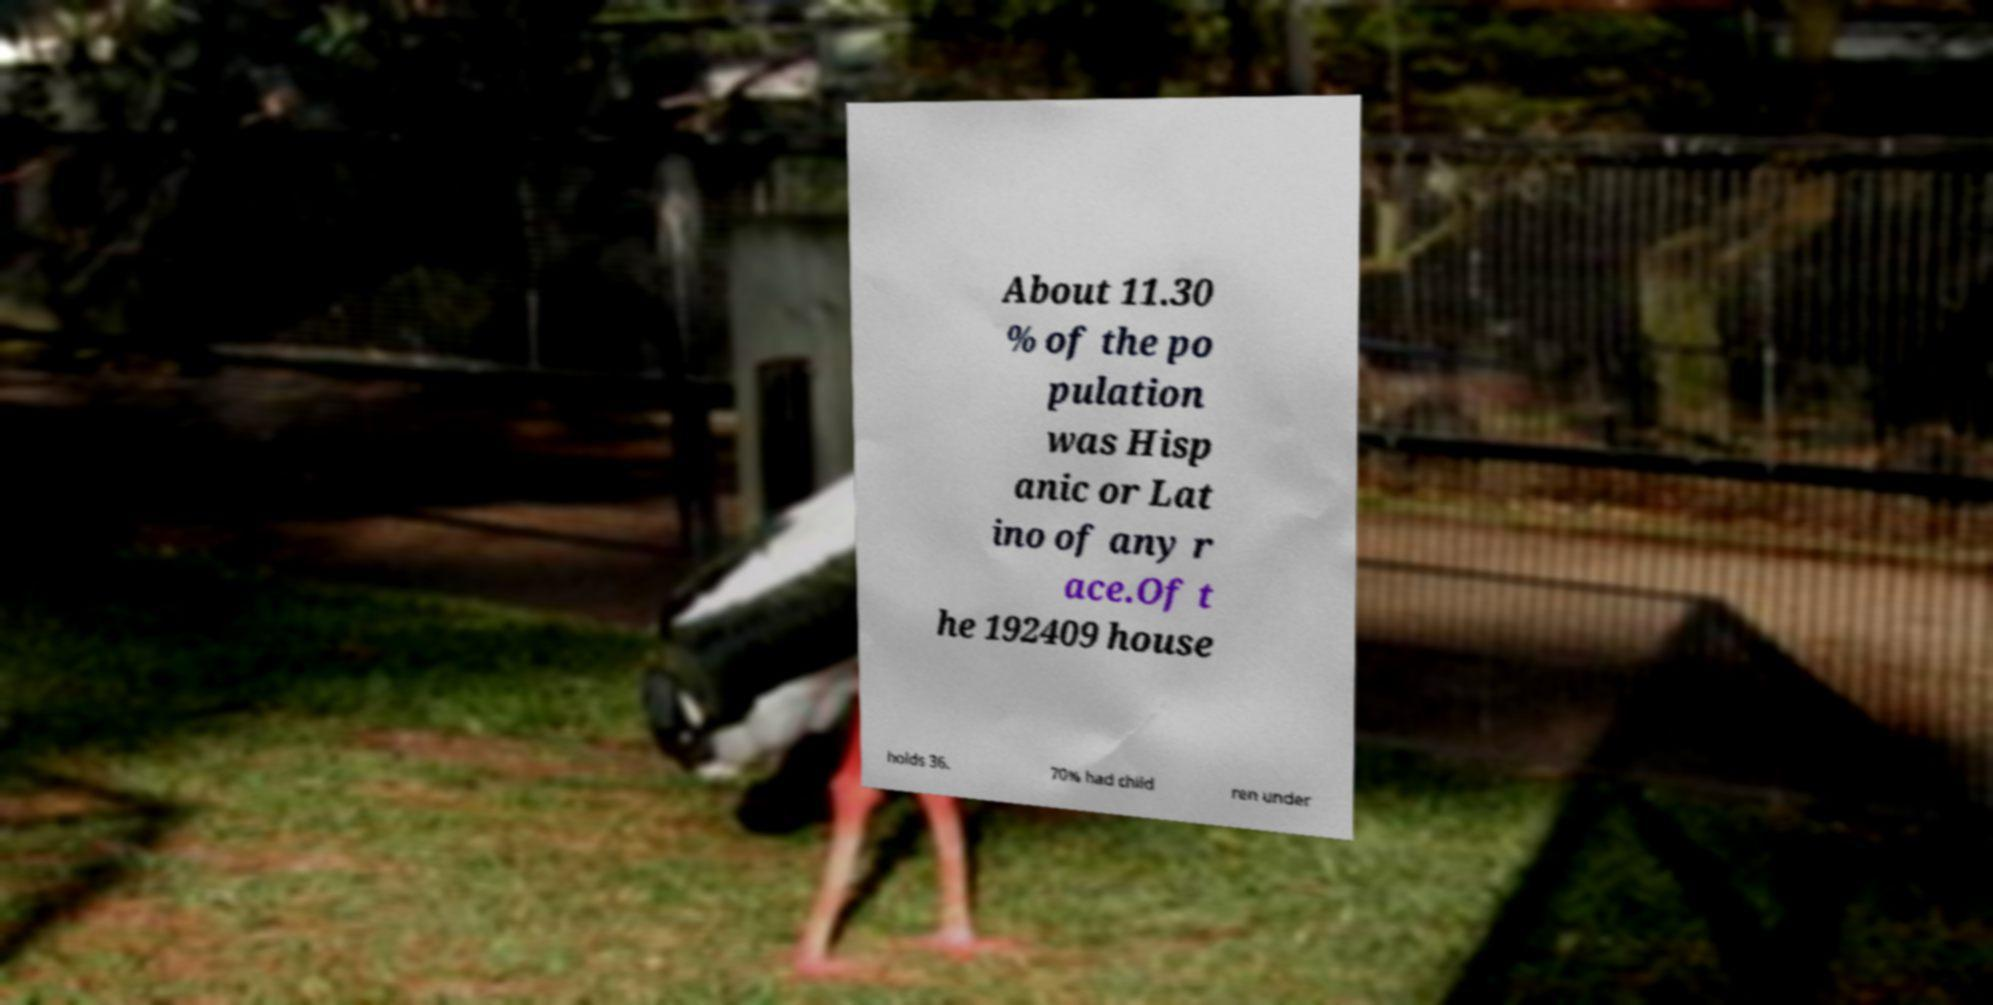For documentation purposes, I need the text within this image transcribed. Could you provide that? About 11.30 % of the po pulation was Hisp anic or Lat ino of any r ace.Of t he 192409 house holds 36. 70% had child ren under 